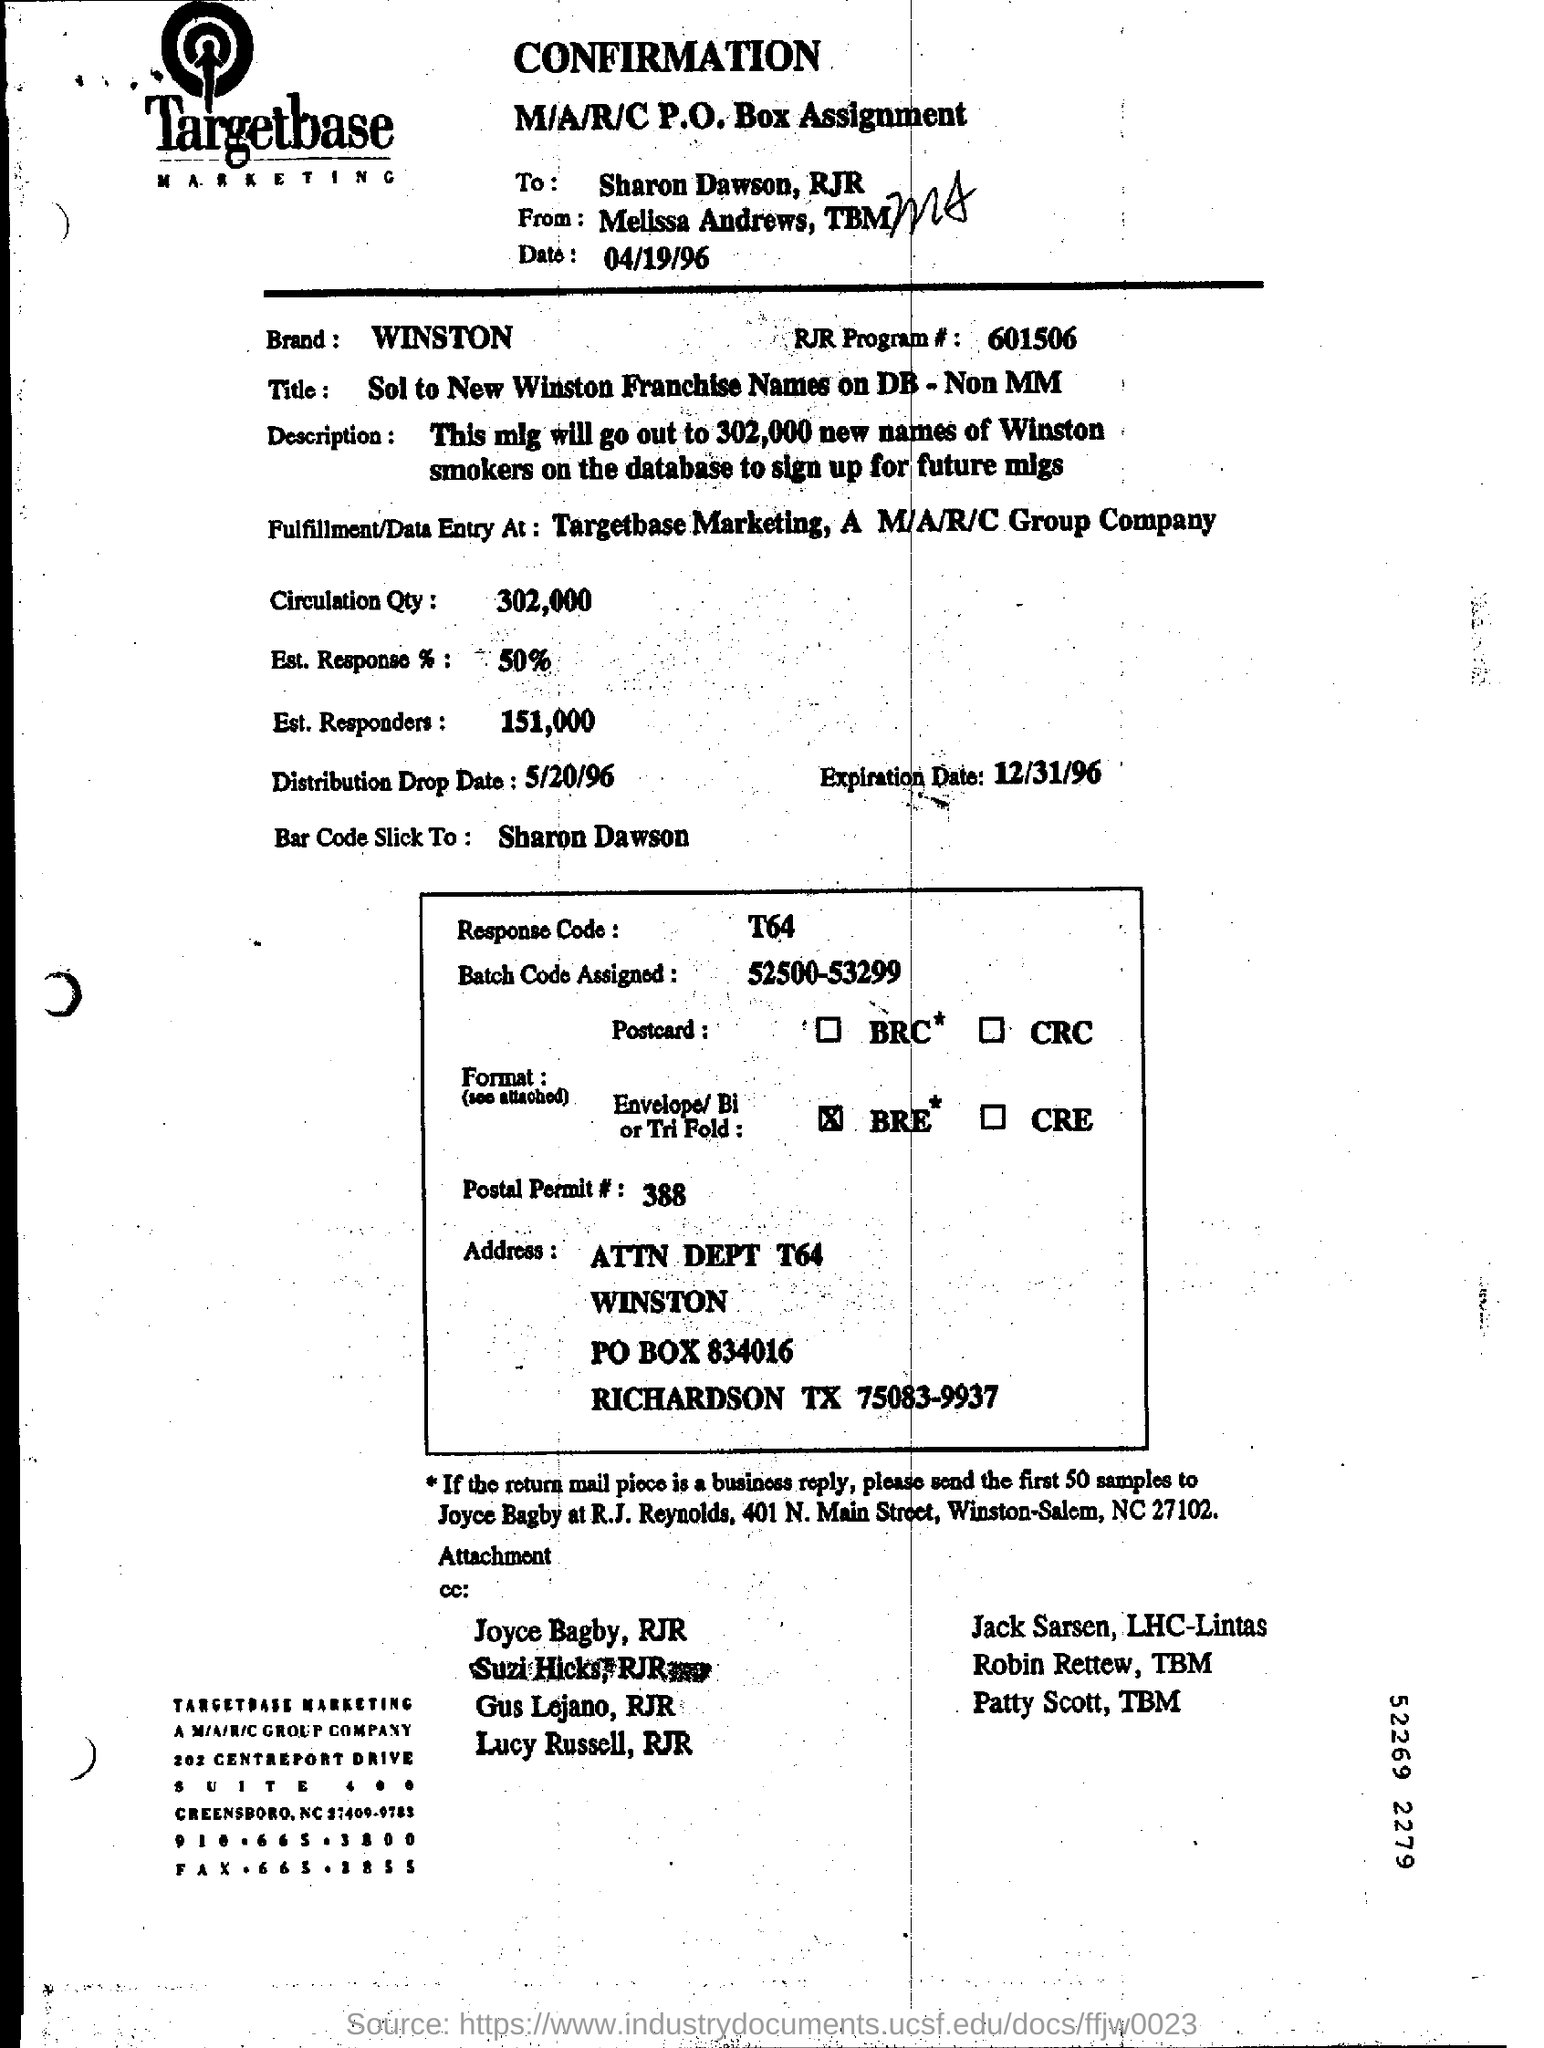How many responders are they expecting? Based on the estimated response rate of 50%, they are expecting approximately 151,000 responders. Is that a high number for such campaigns? It would depend on the context and the goals of the campaign, but for a circulation quantity of 302,000, having an estimated 151,000 responders could be considered a successful outcome. 